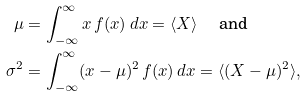Convert formula to latex. <formula><loc_0><loc_0><loc_500><loc_500>\mu & = \int _ { - \infty } ^ { \infty } x \, f ( x ) \, d x = \langle X \rangle \quad \text { and} \\ \sigma ^ { 2 } & = \int _ { - \infty } ^ { \infty } ( x - \mu ) ^ { 2 } \, f ( x ) \, d x = \langle ( X - \mu ) ^ { 2 } \rangle ,</formula> 